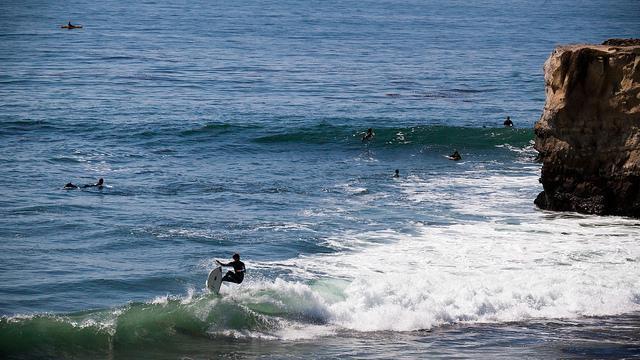How many cars are in this photo?
Give a very brief answer. 0. 